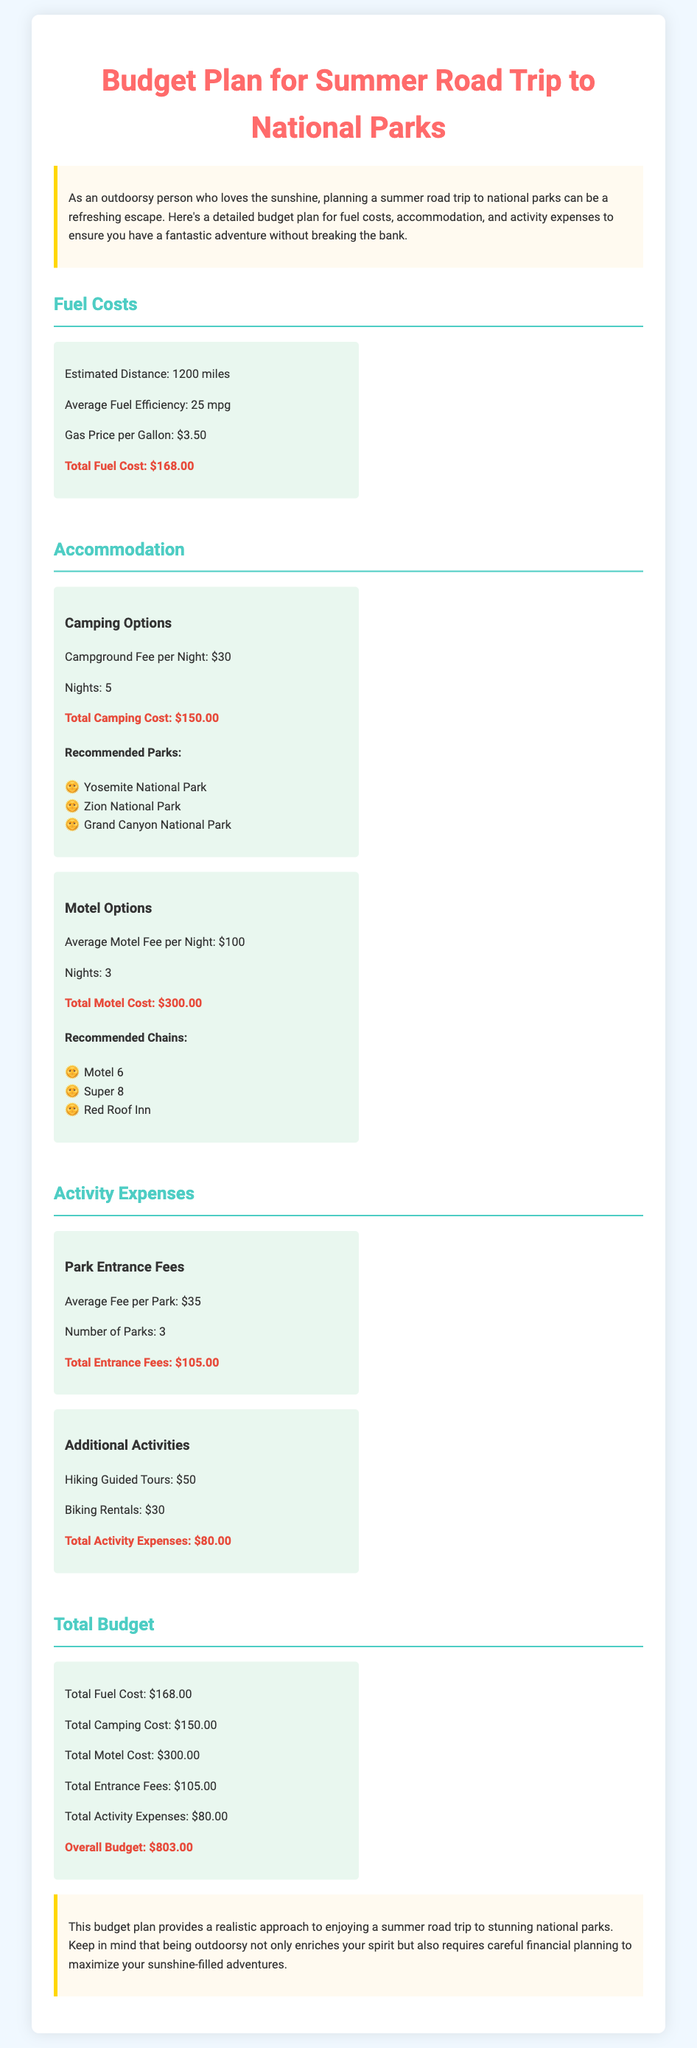What is the estimated distance for the road trip? The document states that the estimated distance is 1200 miles.
Answer: 1200 miles What is the average fuel efficiency? According to the document, the average fuel efficiency is 25 mpg.
Answer: 25 mpg What is the total fuel cost? The total fuel cost is explicitly mentioned as $168.00 in the document.
Answer: $168.00 How much is the campground fee per night? The document lists the campground fee per night as $30.
Answer: $30 What are the total activity expenses? The total for additional activities and entrance fees adds up to $80.00.
Answer: $80.00 How many parks are visited for the entrance fees? The number of parks listed for entrance fees is 3.
Answer: 3 What is the total camping cost? The document provides the total camping cost as $150.00.
Answer: $150.00 What is the overall budget for the trip? The overall budget totals $803.00 as indicated in the document.
Answer: $803.00 Which national parks are recommended for camping? Recommended parks include Yosemite National Park, Zion National Park, and Grand Canyon National Park.
Answer: Yosemite National Park, Zion National Park, Grand Canyon National Park 